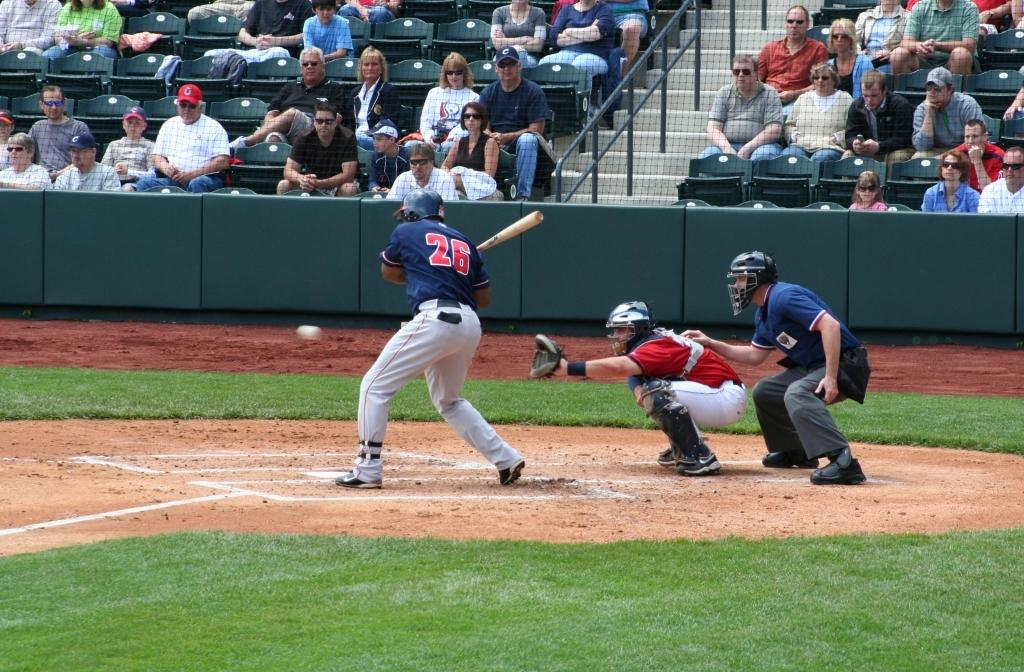<image>
Render a clear and concise summary of the photo. Men playing baseball, one of whom has number twenty six on his shirt. 